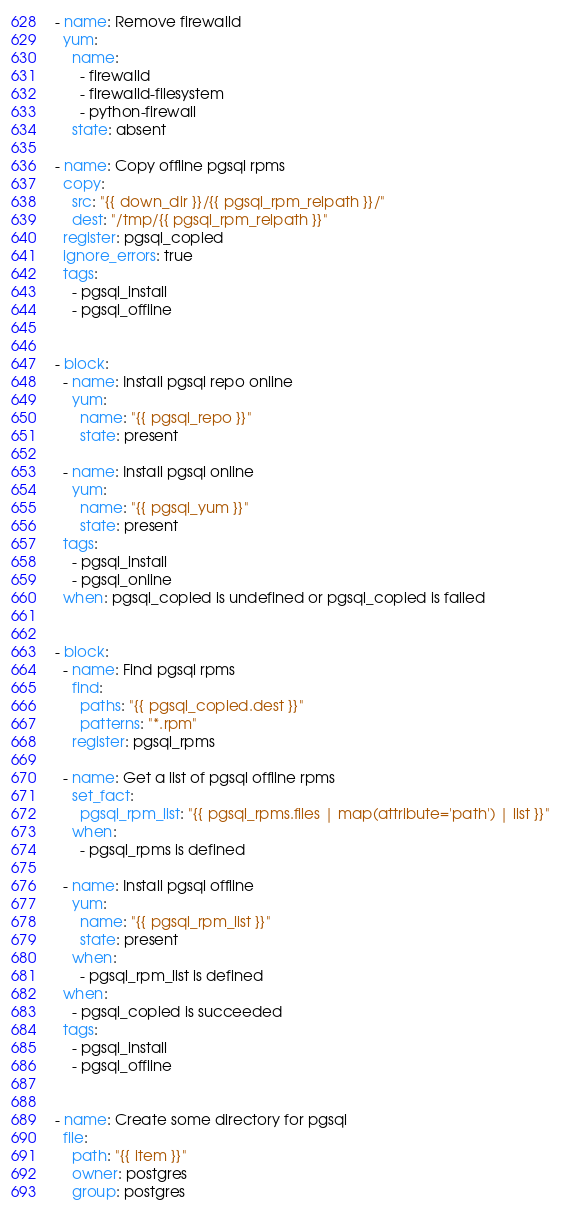Convert code to text. <code><loc_0><loc_0><loc_500><loc_500><_YAML_>- name: Remove firewalld
  yum:
    name:
      - firewalld
      - firewalld-filesystem
      - python-firewall
    state: absent

- name: Copy offline pgsql rpms 
  copy:
    src: "{{ down_dir }}/{{ pgsql_rpm_relpath }}/"
    dest: "/tmp/{{ pgsql_rpm_relpath }}"
  register: pgsql_copied
  ignore_errors: true
  tags: 
    - pgsql_install
    - pgsql_offline


- block:
  - name: Install pgsql repo online
    yum:
      name: "{{ pgsql_repo }}"
      state: present
  
  - name: Install pgsql online
    yum:
      name: "{{ pgsql_yum }}"
      state: present
  tags: 
    - pgsql_install
    - pgsql_online
  when: pgsql_copied is undefined or pgsql_copied is failed


- block:
  - name: Find pgsql rpms
    find:
      paths: "{{ pgsql_copied.dest }}"
      patterns: "*.rpm"
    register: pgsql_rpms
  
  - name: Get a list of pgsql offline rpms
    set_fact: 
      pgsql_rpm_list: "{{ pgsql_rpms.files | map(attribute='path') | list }}"
    when:
      - pgsql_rpms is defined
  
  - name: Install pgsql offline
    yum:
      name: "{{ pgsql_rpm_list }}"
      state: present
    when: 
      - pgsql_rpm_list is defined
  when: 
    - pgsql_copied is succeeded
  tags: 
    - pgsql_install
    - pgsql_offline


- name: Create some directory for pgsql
  file:
    path: "{{ item }}"
    owner: postgres
    group: postgres</code> 